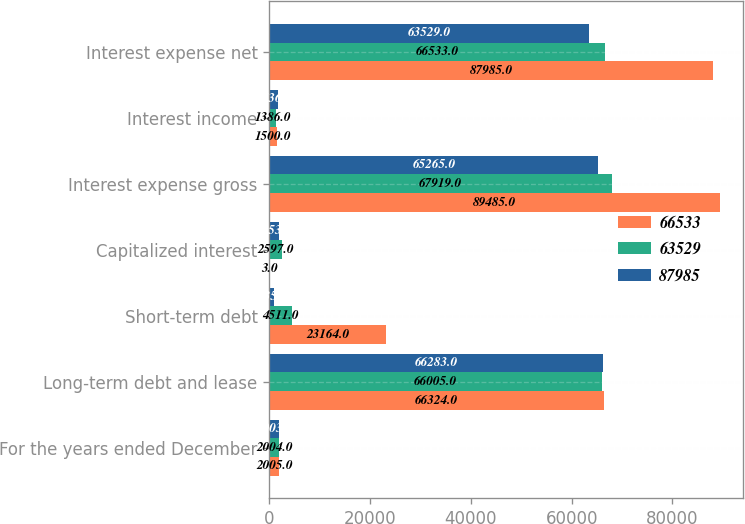<chart> <loc_0><loc_0><loc_500><loc_500><stacked_bar_chart><ecel><fcel>For the years ended December<fcel>Long-term debt and lease<fcel>Short-term debt<fcel>Capitalized interest<fcel>Interest expense gross<fcel>Interest income<fcel>Interest expense net<nl><fcel>66533<fcel>2005<fcel>66324<fcel>23164<fcel>3<fcel>89485<fcel>1500<fcel>87985<nl><fcel>63529<fcel>2004<fcel>66005<fcel>4511<fcel>2597<fcel>67919<fcel>1386<fcel>66533<nl><fcel>87985<fcel>2003<fcel>66283<fcel>935<fcel>1953<fcel>65265<fcel>1736<fcel>63529<nl></chart> 